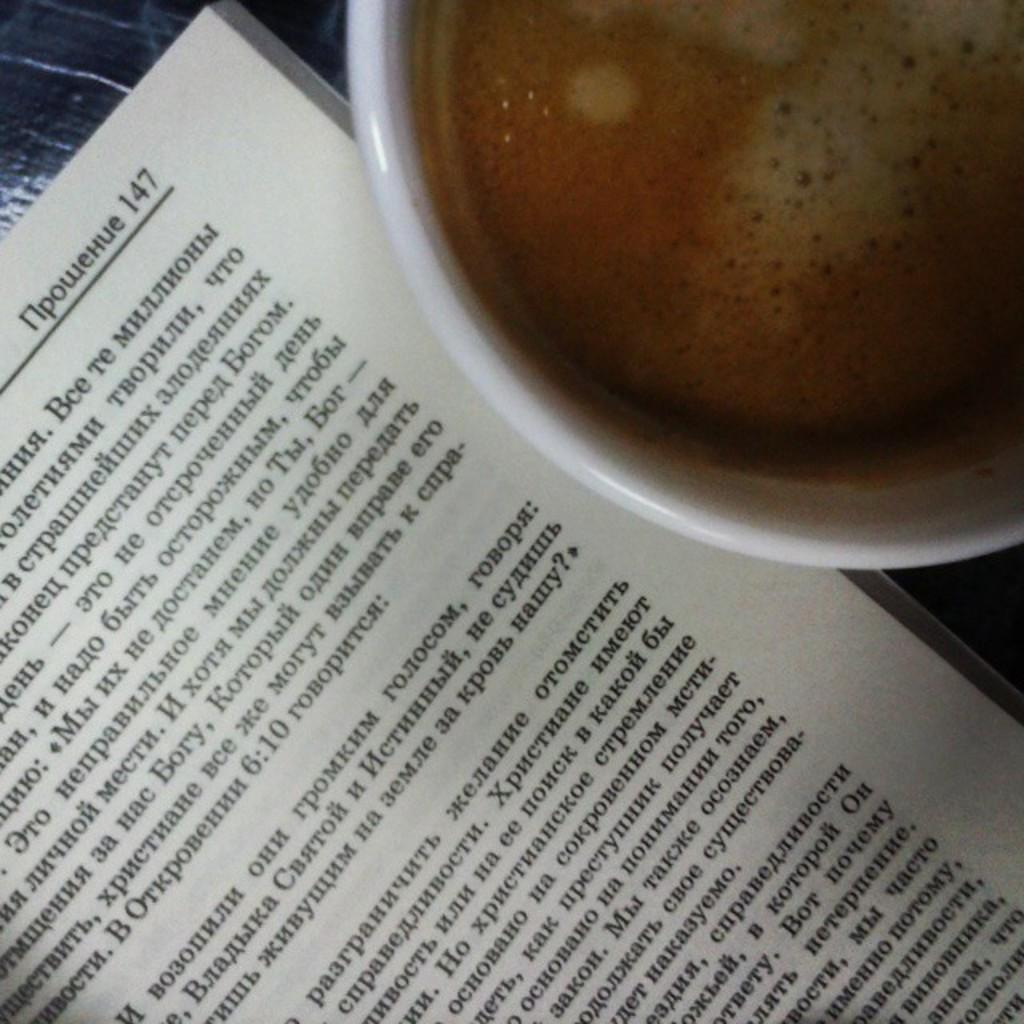What page is it?
Make the answer very short. 147. 